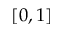<formula> <loc_0><loc_0><loc_500><loc_500>[ 0 , 1 ]</formula> 